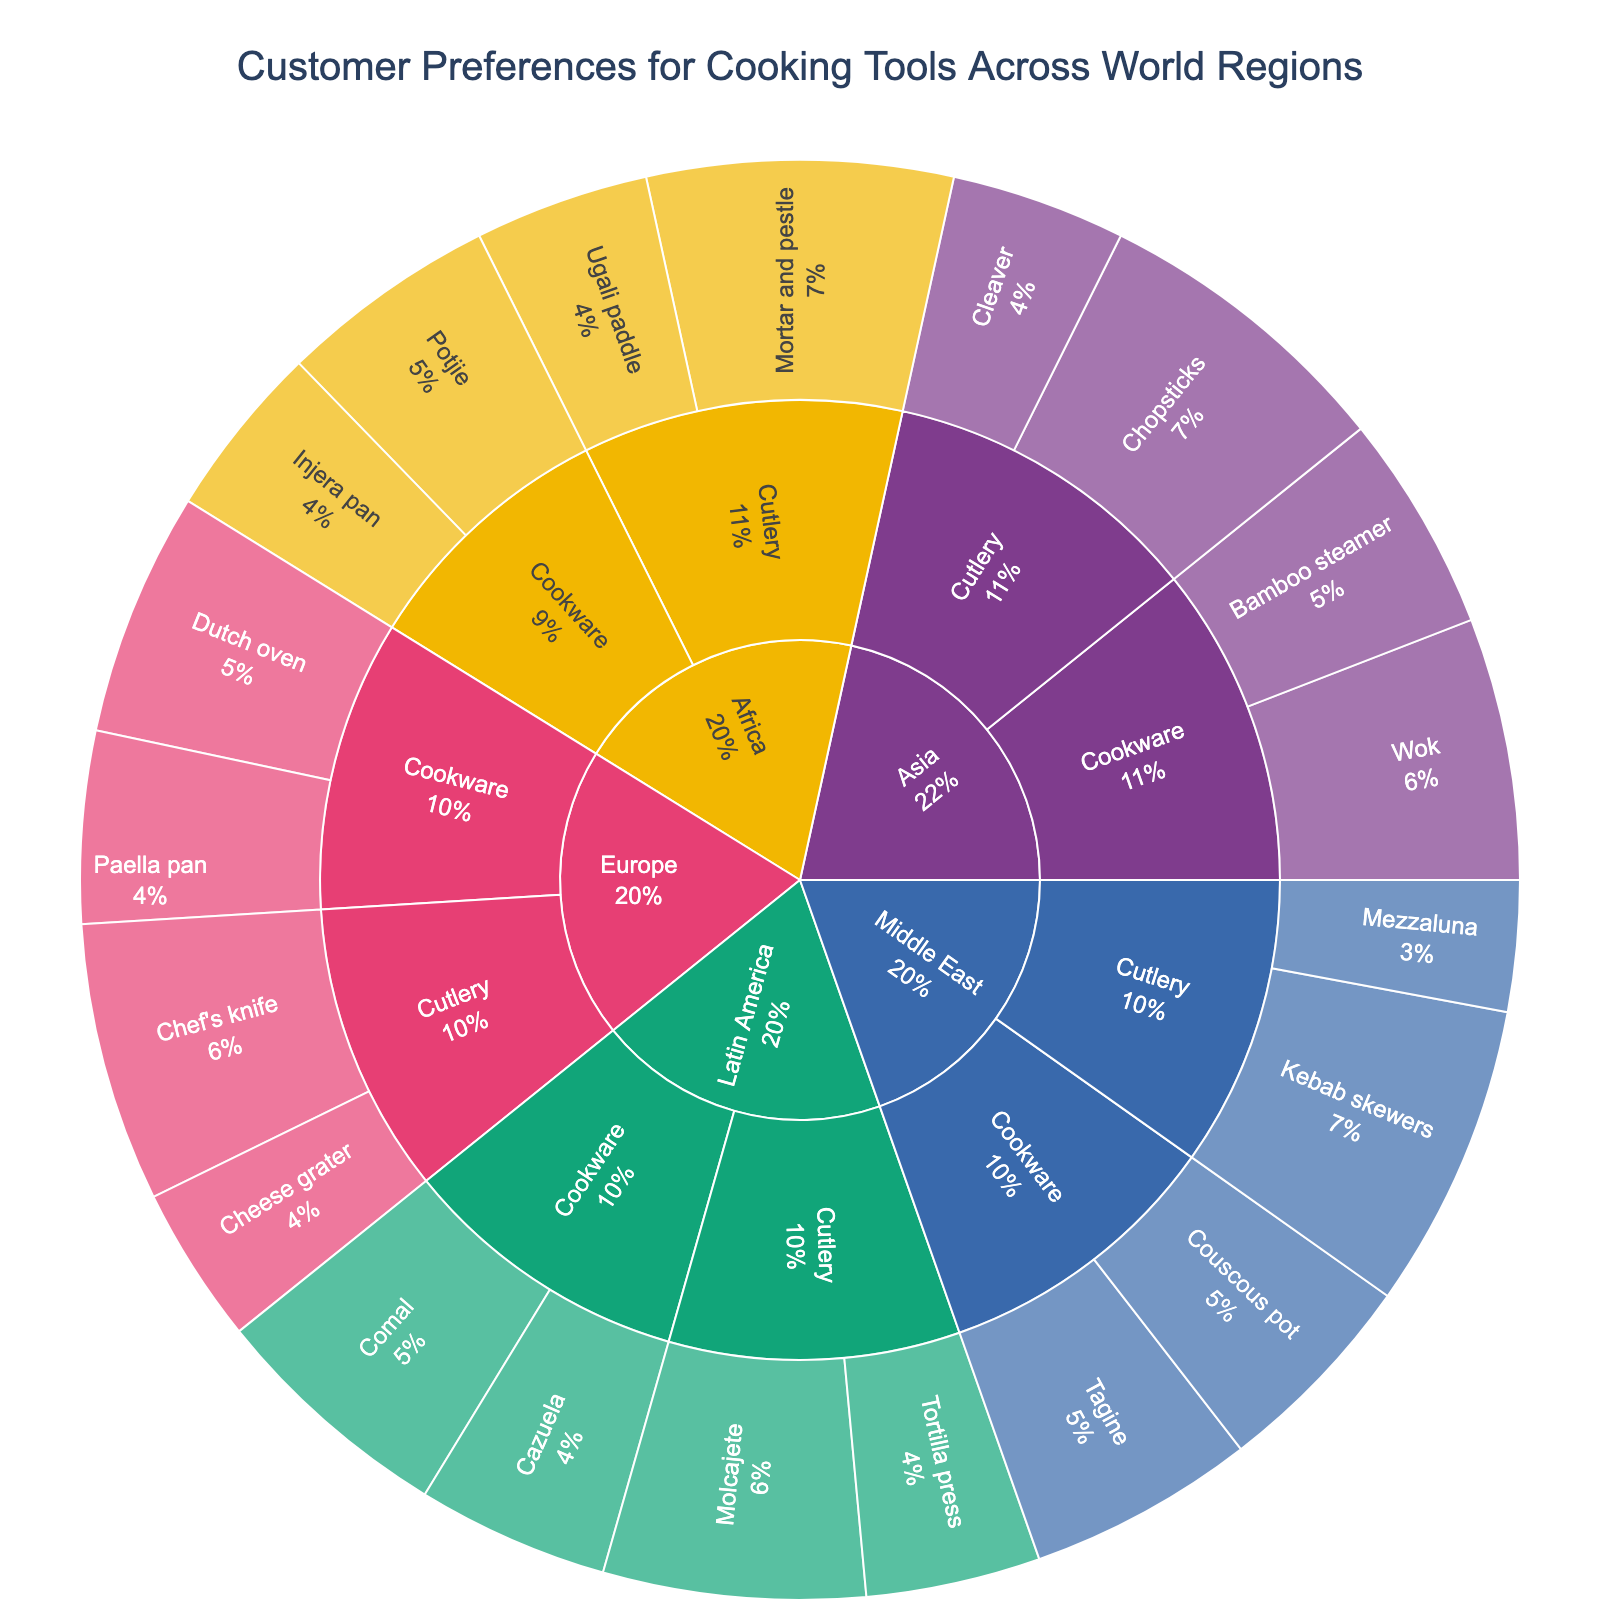What's the most preferred utensil in the Asia region? Looking at the Asia region section of the sunburst plot, the utensil with the highest preference value is highlighted. The chart shows "Chopsticks" with the highest preference of 35.
Answer: Chopsticks Which region shows the highest preference for the Mortar and Pestle? Inspect the segments labeled by region in the sunburst plot. The Mortar and Pestle is a utensil listed under Africa, with a preference of 35. This is higher than any other region's preference for Mortar and Pestle, as no other region lists this utensil.
Answer: Africa Compare the preference values for the top cookware items in Europe and Latin America. Which region has a higher preference for its top cookware item? Look at the Europe and Latin America sections of the sunburst plot. Europe's top cookware item is the Dutch oven with 28, while Latin America's is the Comal, also with 28. Both have the same preference value for their top cookware item.
Answer: Both are equal Which cutlery utensil is the least preferred in the Middle East region? In the Middle East region of the sunburst plot, compare the preference values of cutlery items: Mezzaluna (15) and Kebab skewers (35). Mezzaluna has the lowest preference value.
Answer: Mezzaluna How does the preference for the Wok in Asia compare to the preference for the Chef's knife in Europe? Identify the preference values for the Wok (Asia) and Chef's knife (Europe) in the sunburst plot. The Wok has a preference value of 30, while the Chef's knife has a preference value of 32. Compare these values to see that Chef's knife in Europe is slightly more preferred.
Answer: Chef's knife in Europe is higher Which region has the most diverse category preference, judging by both cookware and cutlery percentages? To determine diversity, look at each region's distribution across cookware and cutlery categories in the sunburst plot. Count the distinct categories and their respective percentages. Middle East shows a roughly even distribution between cookware and cutlery compared to more skewed distributions in other regions.
Answer: Middle East What is the cumulative preference for all cutlery items in Africa? Examine the sections of Africa related to cutlery (Mortar and Pestle, Ugali paddle). Sum their preference values. For Mortar and Pestle (35) and Ugali paddle (20), the sum is 35 + 20 = 55.
Answer: 55 Which region has the most balanced split between cookware and cutlery preferences? By examining the sunburst plot, assess the regions for even distribution between cookware and cutlery preferences. The Middle East shows a balanced split with percentages roughly equal between two categories.
Answer: Middle East 